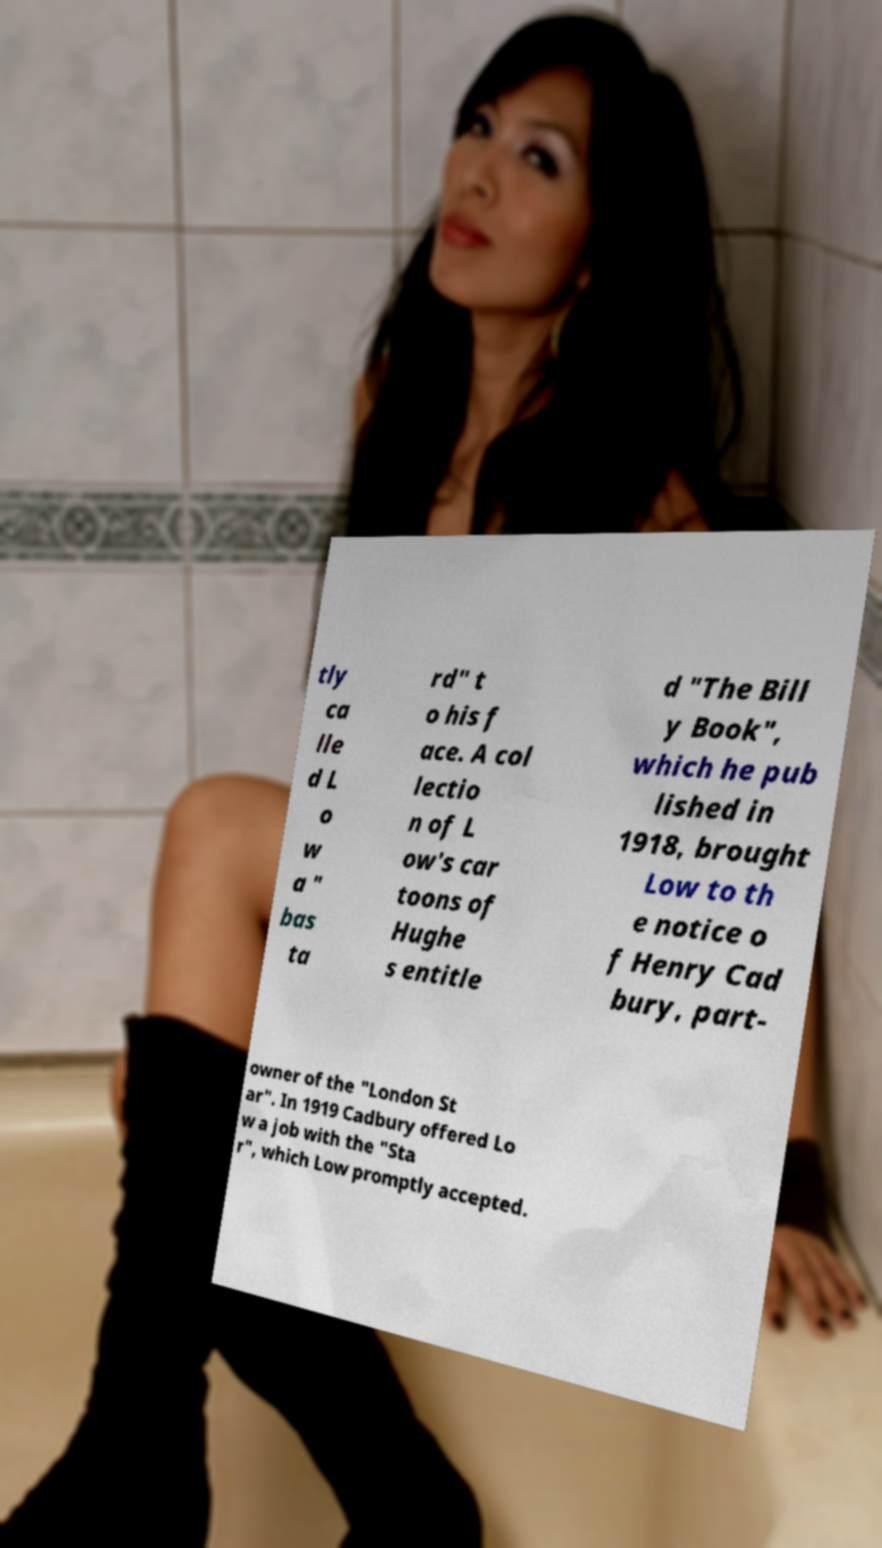There's text embedded in this image that I need extracted. Can you transcribe it verbatim? tly ca lle d L o w a " bas ta rd" t o his f ace. A col lectio n of L ow's car toons of Hughe s entitle d "The Bill y Book", which he pub lished in 1918, brought Low to th e notice o f Henry Cad bury, part- owner of the "London St ar". In 1919 Cadbury offered Lo w a job with the "Sta r", which Low promptly accepted. 